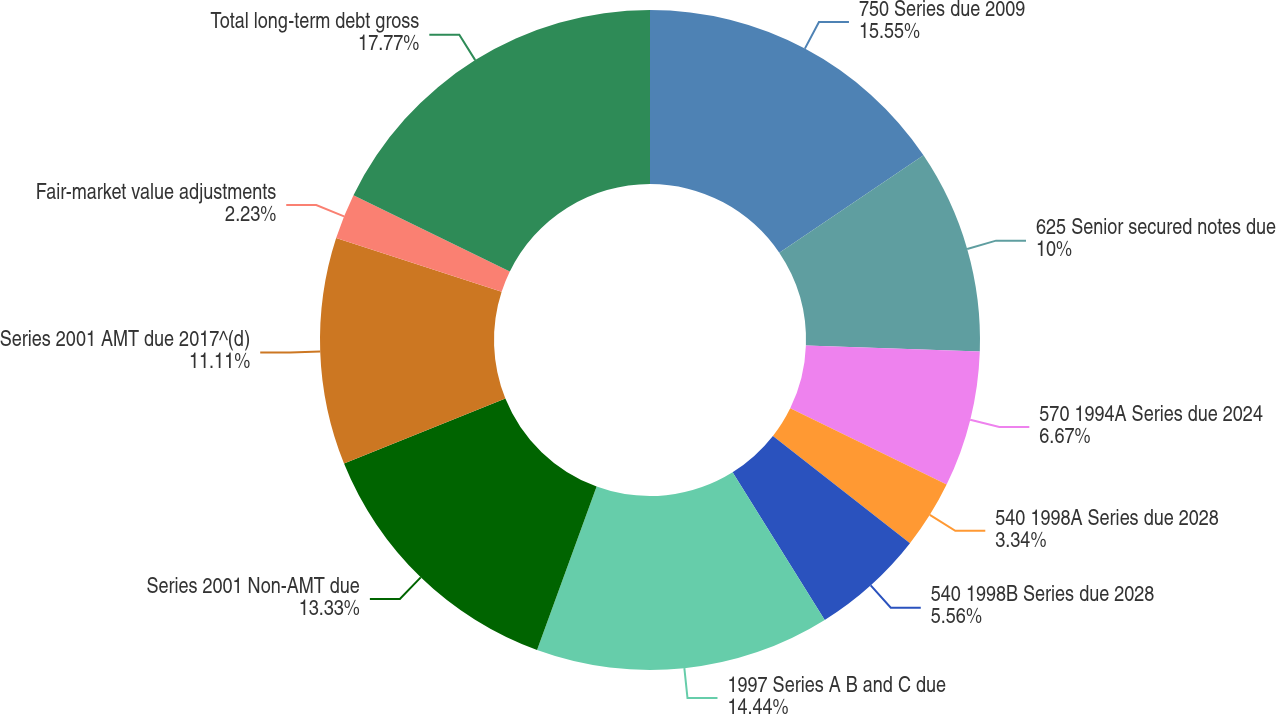Convert chart. <chart><loc_0><loc_0><loc_500><loc_500><pie_chart><fcel>750 Series due 2009<fcel>625 Senior secured notes due<fcel>570 1994A Series due 2024<fcel>540 1998A Series due 2028<fcel>540 1998B Series due 2028<fcel>1997 Series A B and C due<fcel>Series 2001 Non-AMT due<fcel>Series 2001 AMT due 2017^(d)<fcel>Fair-market value adjustments<fcel>Total long-term debt gross<nl><fcel>15.55%<fcel>10.0%<fcel>6.67%<fcel>3.34%<fcel>5.56%<fcel>14.44%<fcel>13.33%<fcel>11.11%<fcel>2.23%<fcel>17.77%<nl></chart> 